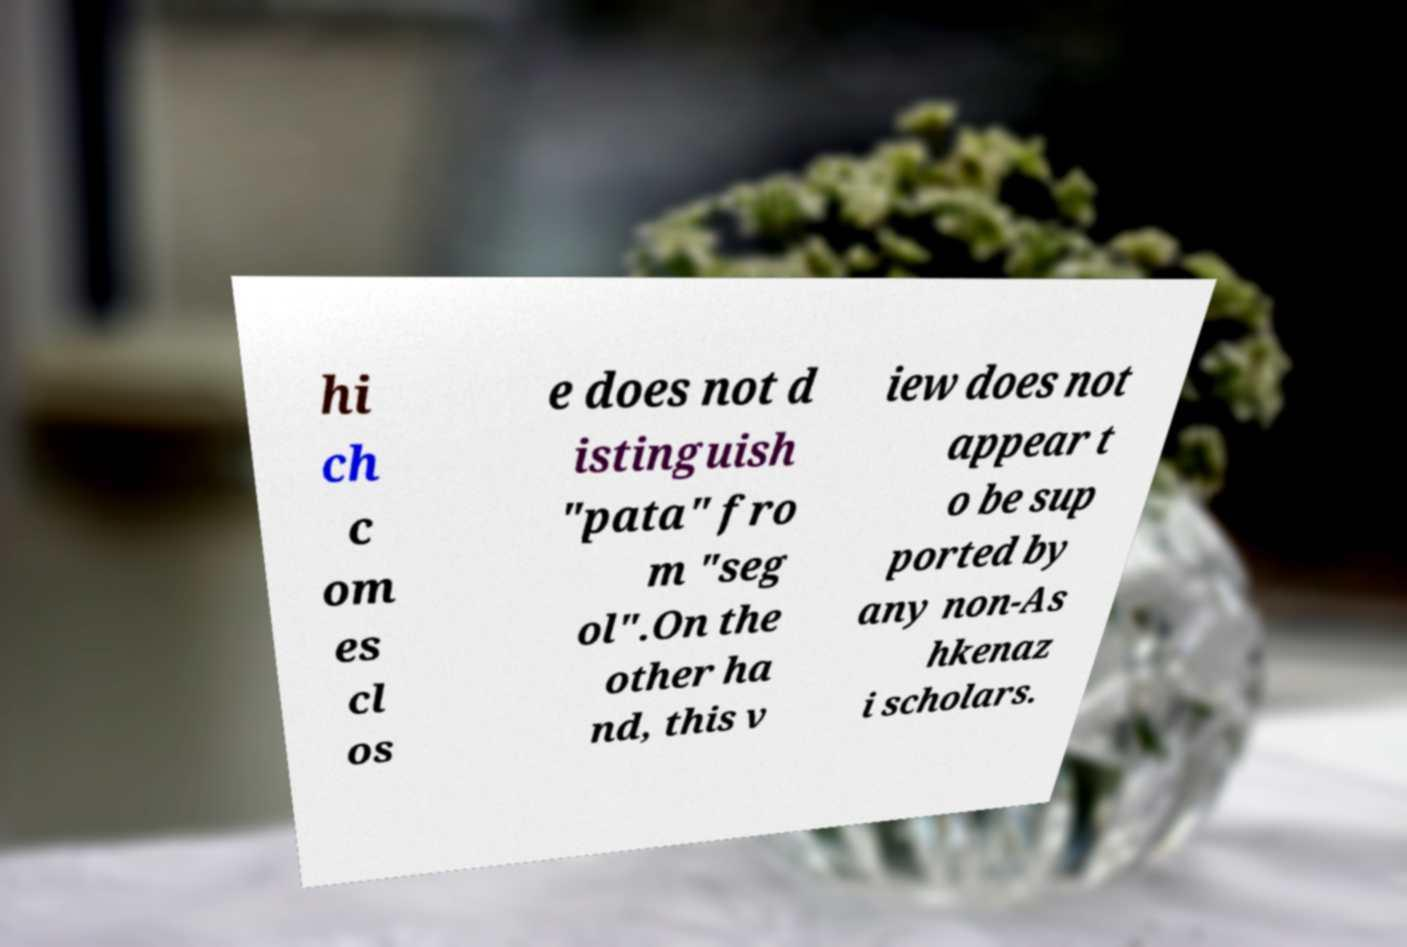Please identify and transcribe the text found in this image. hi ch c om es cl os e does not d istinguish "pata" fro m "seg ol".On the other ha nd, this v iew does not appear t o be sup ported by any non-As hkenaz i scholars. 